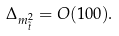Convert formula to latex. <formula><loc_0><loc_0><loc_500><loc_500>\Delta _ { m _ { \tilde { t } } ^ { 2 } } = O ( 1 0 0 ) .</formula> 